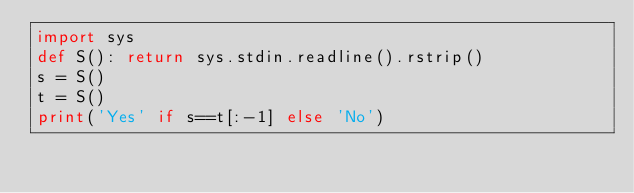<code> <loc_0><loc_0><loc_500><loc_500><_Python_>import sys
def S(): return sys.stdin.readline().rstrip()
s = S()
t = S()
print('Yes' if s==t[:-1] else 'No')
</code> 